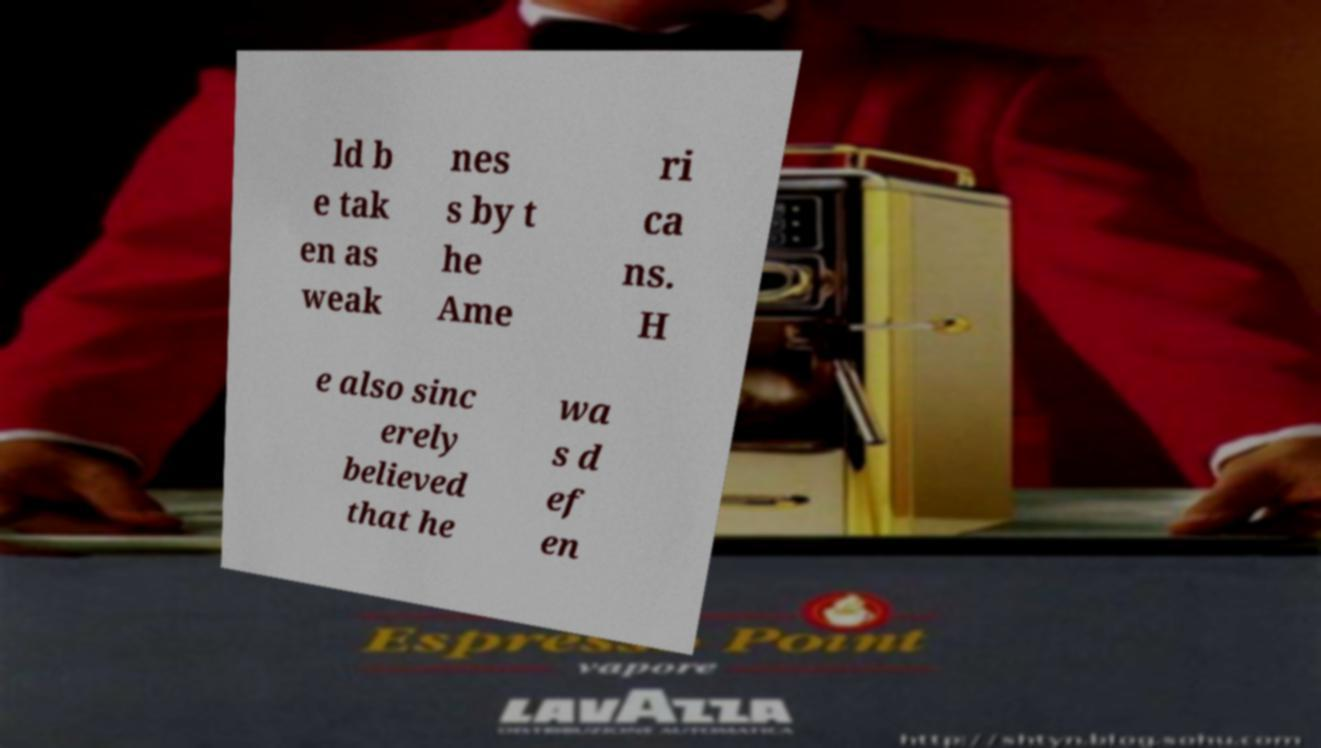Please identify and transcribe the text found in this image. ld b e tak en as weak nes s by t he Ame ri ca ns. H e also sinc erely believed that he wa s d ef en 